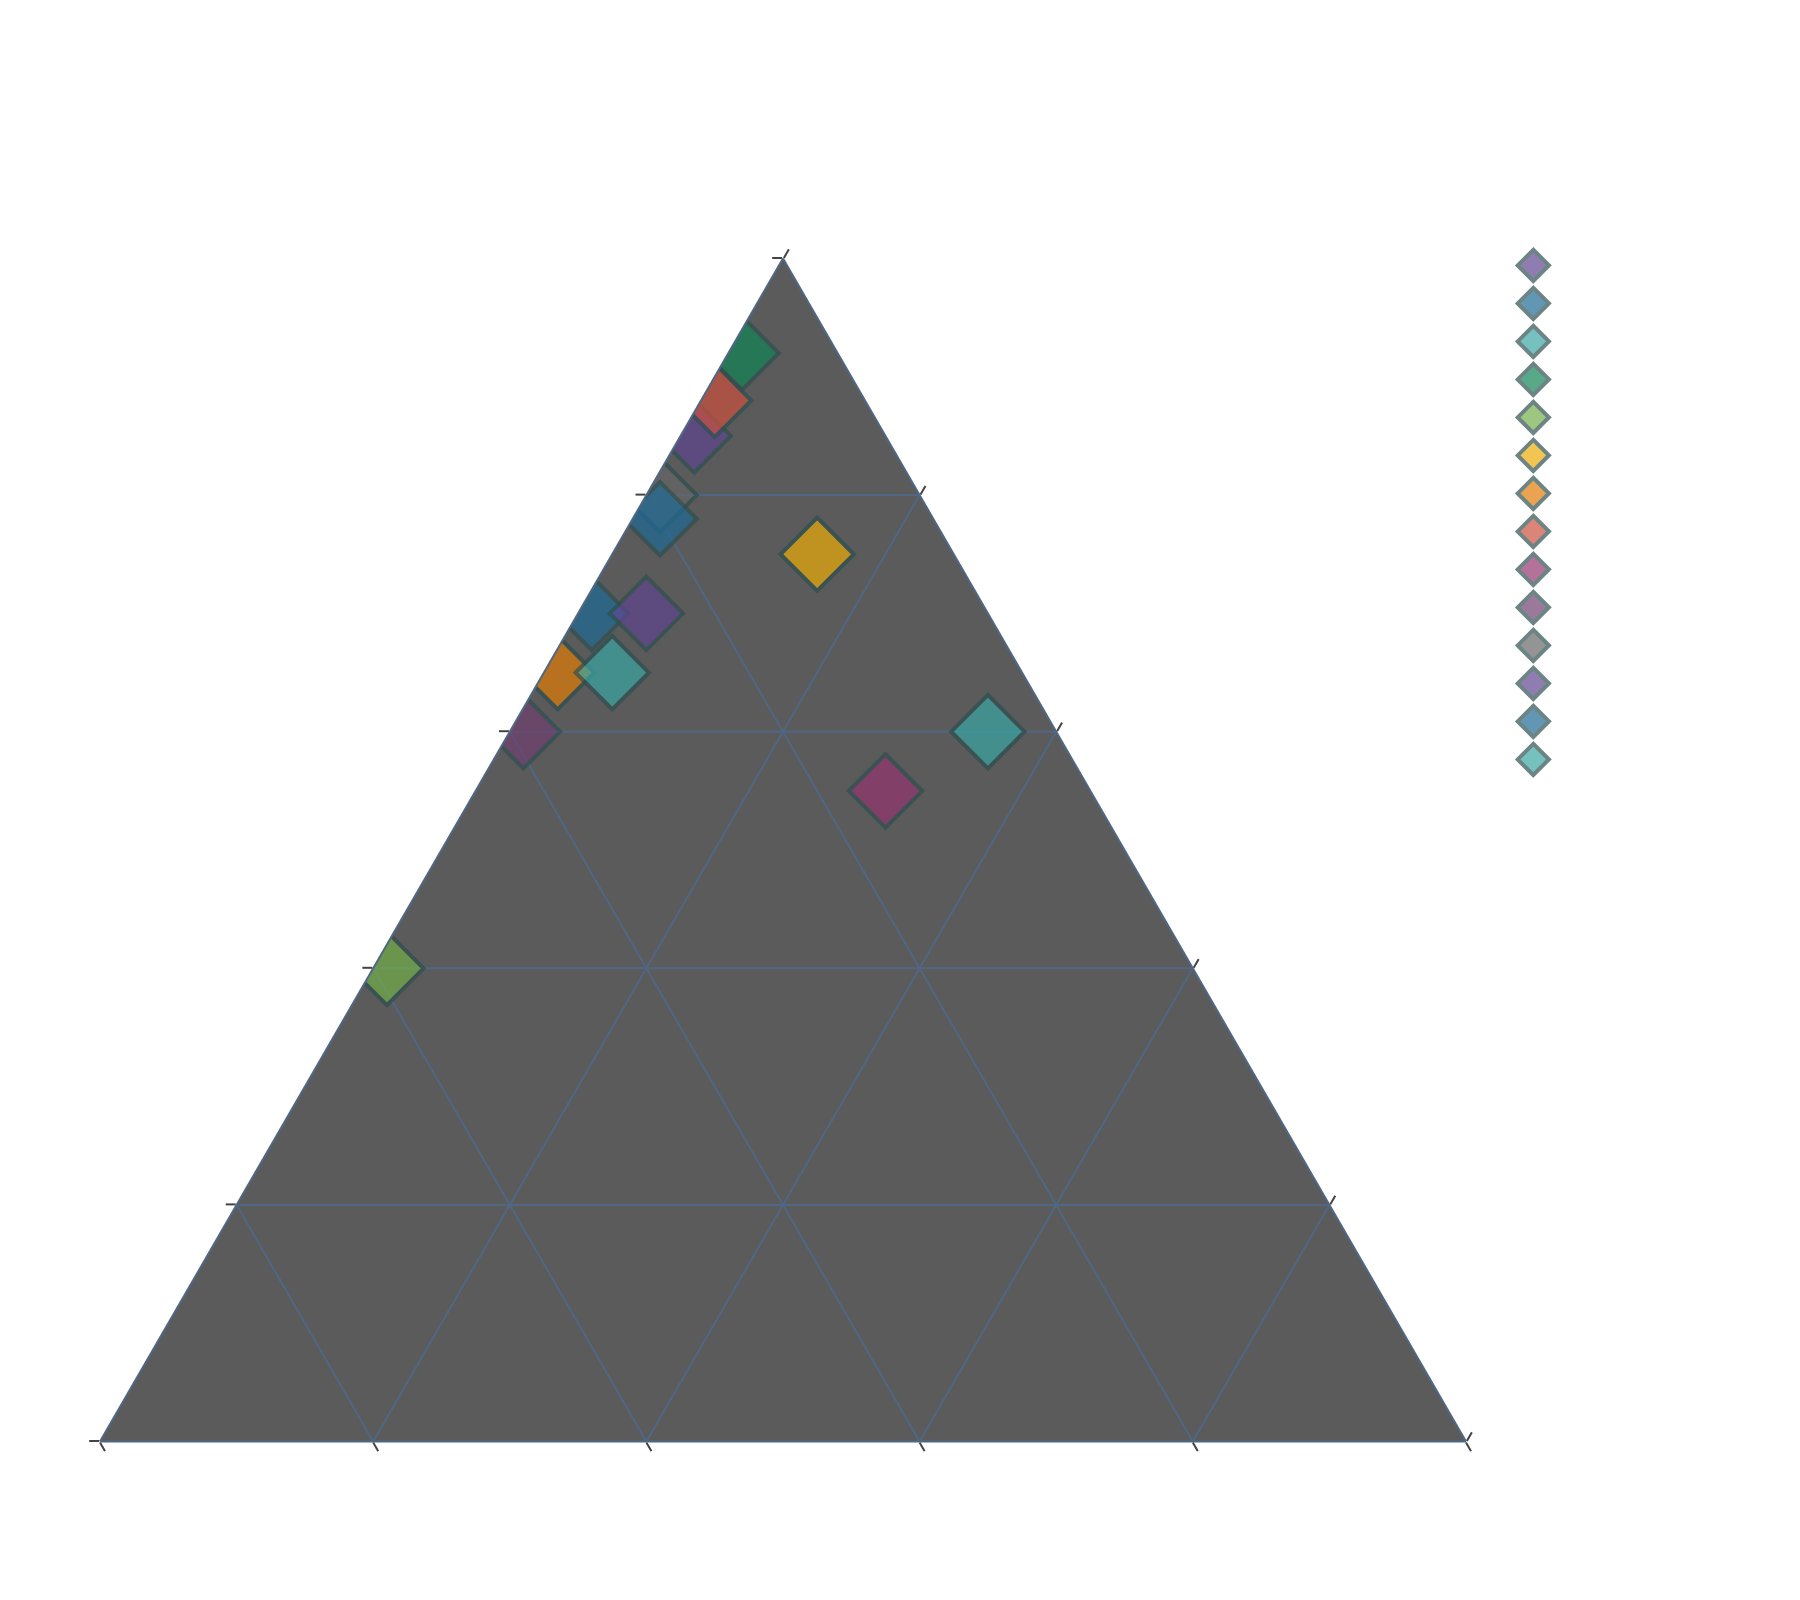What's the title of the figure? The title is located clearly at the top of the figure, which states the main topic of the plot.
Answer: Composition of Successful Patent Applications How many data points (inventors) are displayed in the figure? The data points are represented by markers on the ternary plot, each corresponding to an inventor listed in the data table.
Answer: 14 Which company has the highest proportion of utility patents? By looking at the axis for utility patents, we can identify which point is closest to the 100% mark on the utility axis.
Answer: Boeing Which inventor has the highest proportion of plant patents? By examining the axis for plant patents and finding the point closest to 100%, we identify the inventor with the most plant patents.
Answer: Monsanto How does the proportion of design patents for Tesla compare to that for Nike? Locate the points for Tesla and Nike and compare their positions on the design axis to see which has a higher value.
Answer: Tesla has a lower proportion of design patents than Nike What is the combined proportion of utility and plant patents for 3M? Sum the utility and plant patent proportions from the data values for 3M.
Answer: 75% Among Apple, Samsung, and Google, who focuses the most on design patents? Compare the positions for Apple, Samsung, and Google along the design axis to see which one is highest.
Answer: Samsung What is the average proportion of design patents for Apple, Samsung, and Dyson? Add the design proportions for Apple, Samsung, and Dyson, then divide by 3.
Answer: 34% Among Procter & Gamble, DuPont, and Monsanto, who has the lowest proportion of utility patents? Compare these three companies by looking at their positions on the utility axis and finding the lowest value.
Answer: DuPont Which company has a more balanced distribution across all three patent types? Assess the plots and identify which company is closest to the center of the ternary plot, indicating a more balanced distribution.
Answer: DuPont 